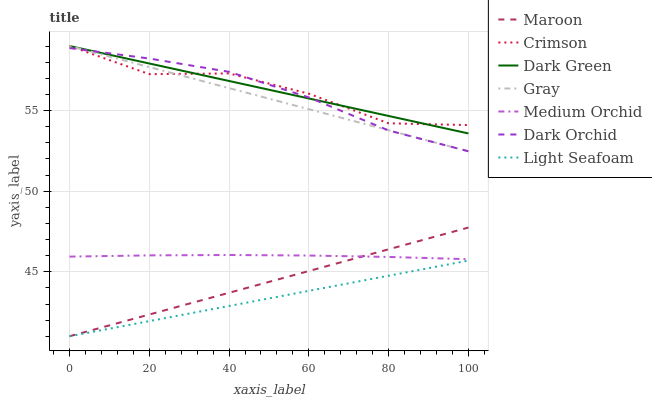Does Light Seafoam have the minimum area under the curve?
Answer yes or no. Yes. Does Dark Green have the maximum area under the curve?
Answer yes or no. Yes. Does Medium Orchid have the minimum area under the curve?
Answer yes or no. No. Does Medium Orchid have the maximum area under the curve?
Answer yes or no. No. Is Maroon the smoothest?
Answer yes or no. Yes. Is Crimson the roughest?
Answer yes or no. Yes. Is Medium Orchid the smoothest?
Answer yes or no. No. Is Medium Orchid the roughest?
Answer yes or no. No. Does Maroon have the lowest value?
Answer yes or no. Yes. Does Medium Orchid have the lowest value?
Answer yes or no. No. Does Dark Green have the highest value?
Answer yes or no. Yes. Does Medium Orchid have the highest value?
Answer yes or no. No. Is Maroon less than Dark Green?
Answer yes or no. Yes. Is Gray greater than Maroon?
Answer yes or no. Yes. Does Maroon intersect Medium Orchid?
Answer yes or no. Yes. Is Maroon less than Medium Orchid?
Answer yes or no. No. Is Maroon greater than Medium Orchid?
Answer yes or no. No. Does Maroon intersect Dark Green?
Answer yes or no. No. 